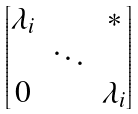Convert formula to latex. <formula><loc_0><loc_0><loc_500><loc_500>\begin{bmatrix} \lambda _ { i } & & * \\ & \ddots \\ 0 & & \lambda _ { i } \end{bmatrix}</formula> 